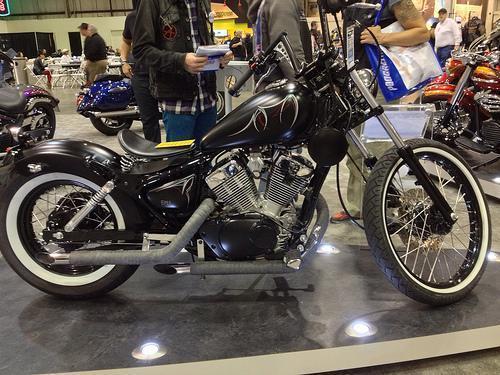How many motorcycles are visible?
Give a very brief answer. 4. 